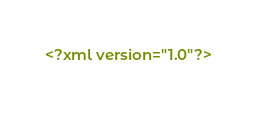Convert code to text. <code><loc_0><loc_0><loc_500><loc_500><_HTML_><?xml version="1.0"?></code> 